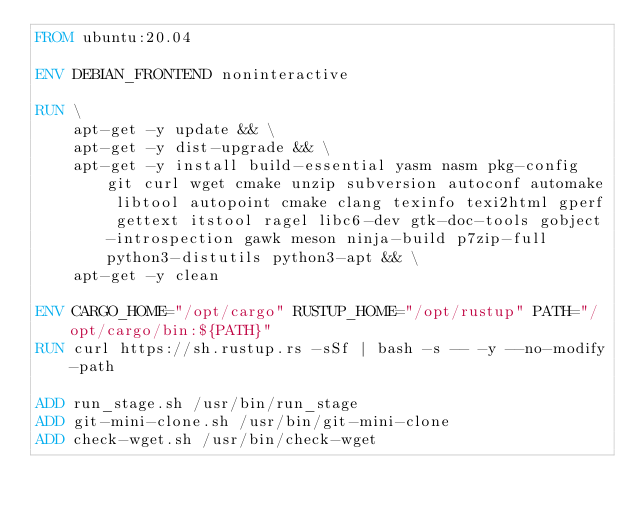Convert code to text. <code><loc_0><loc_0><loc_500><loc_500><_Dockerfile_>FROM ubuntu:20.04

ENV DEBIAN_FRONTEND noninteractive

RUN \
    apt-get -y update && \
    apt-get -y dist-upgrade && \
    apt-get -y install build-essential yasm nasm pkg-config git curl wget cmake unzip subversion autoconf automake libtool autopoint cmake clang texinfo texi2html gperf gettext itstool ragel libc6-dev gtk-doc-tools gobject-introspection gawk meson ninja-build p7zip-full python3-distutils python3-apt && \
    apt-get -y clean

ENV CARGO_HOME="/opt/cargo" RUSTUP_HOME="/opt/rustup" PATH="/opt/cargo/bin:${PATH}"
RUN curl https://sh.rustup.rs -sSf | bash -s -- -y --no-modify-path

ADD run_stage.sh /usr/bin/run_stage
ADD git-mini-clone.sh /usr/bin/git-mini-clone
ADD check-wget.sh /usr/bin/check-wget
</code> 